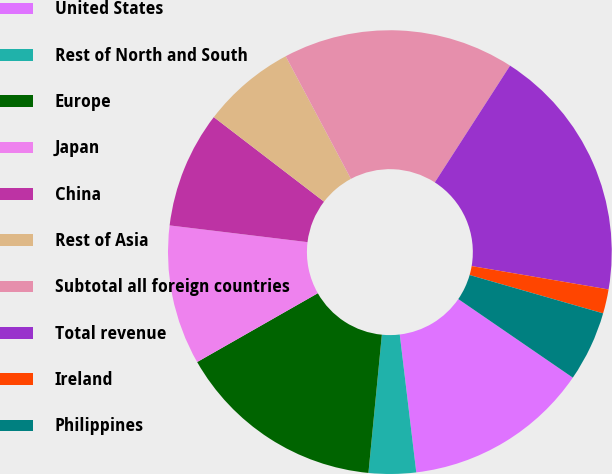Convert chart to OTSL. <chart><loc_0><loc_0><loc_500><loc_500><pie_chart><fcel>United States<fcel>Rest of North and South<fcel>Europe<fcel>Japan<fcel>China<fcel>Rest of Asia<fcel>Subtotal all foreign countries<fcel>Total revenue<fcel>Ireland<fcel>Philippines<nl><fcel>13.53%<fcel>3.44%<fcel>15.21%<fcel>10.17%<fcel>8.49%<fcel>6.81%<fcel>16.89%<fcel>18.58%<fcel>1.76%<fcel>5.12%<nl></chart> 